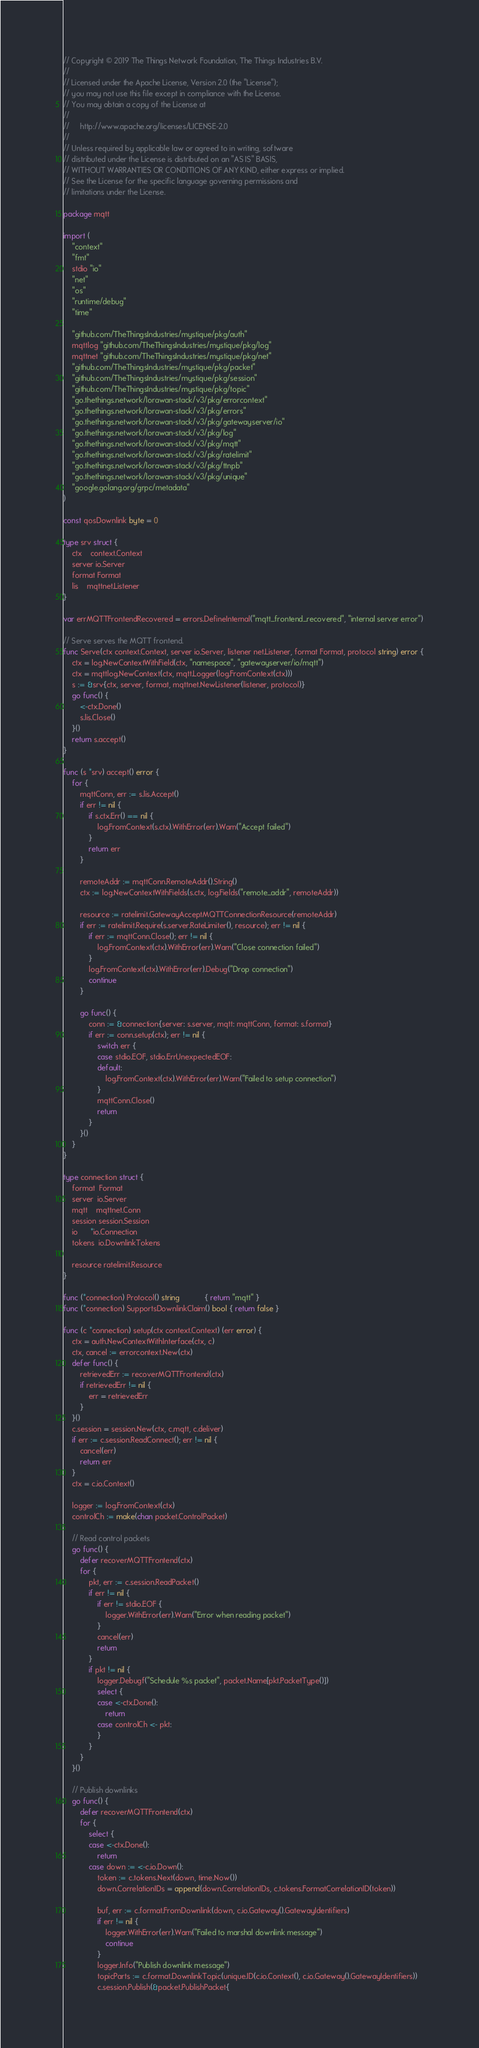<code> <loc_0><loc_0><loc_500><loc_500><_Go_>// Copyright © 2019 The Things Network Foundation, The Things Industries B.V.
//
// Licensed under the Apache License, Version 2.0 (the "License");
// you may not use this file except in compliance with the License.
// You may obtain a copy of the License at
//
//     http://www.apache.org/licenses/LICENSE-2.0
//
// Unless required by applicable law or agreed to in writing, software
// distributed under the License is distributed on an "AS IS" BASIS,
// WITHOUT WARRANTIES OR CONDITIONS OF ANY KIND, either express or implied.
// See the License for the specific language governing permissions and
// limitations under the License.

package mqtt

import (
	"context"
	"fmt"
	stdio "io"
	"net"
	"os"
	"runtime/debug"
	"time"

	"github.com/TheThingsIndustries/mystique/pkg/auth"
	mqttlog "github.com/TheThingsIndustries/mystique/pkg/log"
	mqttnet "github.com/TheThingsIndustries/mystique/pkg/net"
	"github.com/TheThingsIndustries/mystique/pkg/packet"
	"github.com/TheThingsIndustries/mystique/pkg/session"
	"github.com/TheThingsIndustries/mystique/pkg/topic"
	"go.thethings.network/lorawan-stack/v3/pkg/errorcontext"
	"go.thethings.network/lorawan-stack/v3/pkg/errors"
	"go.thethings.network/lorawan-stack/v3/pkg/gatewayserver/io"
	"go.thethings.network/lorawan-stack/v3/pkg/log"
	"go.thethings.network/lorawan-stack/v3/pkg/mqtt"
	"go.thethings.network/lorawan-stack/v3/pkg/ratelimit"
	"go.thethings.network/lorawan-stack/v3/pkg/ttnpb"
	"go.thethings.network/lorawan-stack/v3/pkg/unique"
	"google.golang.org/grpc/metadata"
)

const qosDownlink byte = 0

type srv struct {
	ctx    context.Context
	server io.Server
	format Format
	lis    mqttnet.Listener
}

var errMQTTFrontendRecovered = errors.DefineInternal("mqtt_frontend_recovered", "internal server error")

// Serve serves the MQTT frontend.
func Serve(ctx context.Context, server io.Server, listener net.Listener, format Format, protocol string) error {
	ctx = log.NewContextWithField(ctx, "namespace", "gatewayserver/io/mqtt")
	ctx = mqttlog.NewContext(ctx, mqtt.Logger(log.FromContext(ctx)))
	s := &srv{ctx, server, format, mqttnet.NewListener(listener, protocol)}
	go func() {
		<-ctx.Done()
		s.lis.Close()
	}()
	return s.accept()
}

func (s *srv) accept() error {
	for {
		mqttConn, err := s.lis.Accept()
		if err != nil {
			if s.ctx.Err() == nil {
				log.FromContext(s.ctx).WithError(err).Warn("Accept failed")
			}
			return err
		}

		remoteAddr := mqttConn.RemoteAddr().String()
		ctx := log.NewContextWithFields(s.ctx, log.Fields("remote_addr", remoteAddr))

		resource := ratelimit.GatewayAcceptMQTTConnectionResource(remoteAddr)
		if err := ratelimit.Require(s.server.RateLimiter(), resource); err != nil {
			if err := mqttConn.Close(); err != nil {
				log.FromContext(ctx).WithError(err).Warn("Close connection failed")
			}
			log.FromContext(ctx).WithError(err).Debug("Drop connection")
			continue
		}

		go func() {
			conn := &connection{server: s.server, mqtt: mqttConn, format: s.format}
			if err := conn.setup(ctx); err != nil {
				switch err {
				case stdio.EOF, stdio.ErrUnexpectedEOF:
				default:
					log.FromContext(ctx).WithError(err).Warn("Failed to setup connection")
				}
				mqttConn.Close()
				return
			}
		}()
	}
}

type connection struct {
	format  Format
	server  io.Server
	mqtt    mqttnet.Conn
	session session.Session
	io      *io.Connection
	tokens  io.DownlinkTokens

	resource ratelimit.Resource
}

func (*connection) Protocol() string            { return "mqtt" }
func (*connection) SupportsDownlinkClaim() bool { return false }

func (c *connection) setup(ctx context.Context) (err error) {
	ctx = auth.NewContextWithInterface(ctx, c)
	ctx, cancel := errorcontext.New(ctx)
	defer func() {
		retrievedErr := recoverMQTTFrontend(ctx)
		if retrievedErr != nil {
			err = retrievedErr
		}
	}()
	c.session = session.New(ctx, c.mqtt, c.deliver)
	if err := c.session.ReadConnect(); err != nil {
		cancel(err)
		return err
	}
	ctx = c.io.Context()

	logger := log.FromContext(ctx)
	controlCh := make(chan packet.ControlPacket)

	// Read control packets
	go func() {
		defer recoverMQTTFrontend(ctx)
		for {
			pkt, err := c.session.ReadPacket()
			if err != nil {
				if err != stdio.EOF {
					logger.WithError(err).Warn("Error when reading packet")
				}
				cancel(err)
				return
			}
			if pkt != nil {
				logger.Debugf("Schedule %s packet", packet.Name[pkt.PacketType()])
				select {
				case <-ctx.Done():
					return
				case controlCh <- pkt:
				}
			}
		}
	}()

	// Publish downlinks
	go func() {
		defer recoverMQTTFrontend(ctx)
		for {
			select {
			case <-ctx.Done():
				return
			case down := <-c.io.Down():
				token := c.tokens.Next(down, time.Now())
				down.CorrelationIDs = append(down.CorrelationIDs, c.tokens.FormatCorrelationID(token))

				buf, err := c.format.FromDownlink(down, c.io.Gateway().GatewayIdentifiers)
				if err != nil {
					logger.WithError(err).Warn("Failed to marshal downlink message")
					continue
				}
				logger.Info("Publish downlink message")
				topicParts := c.format.DownlinkTopic(unique.ID(c.io.Context(), c.io.Gateway().GatewayIdentifiers))
				c.session.Publish(&packet.PublishPacket{</code> 